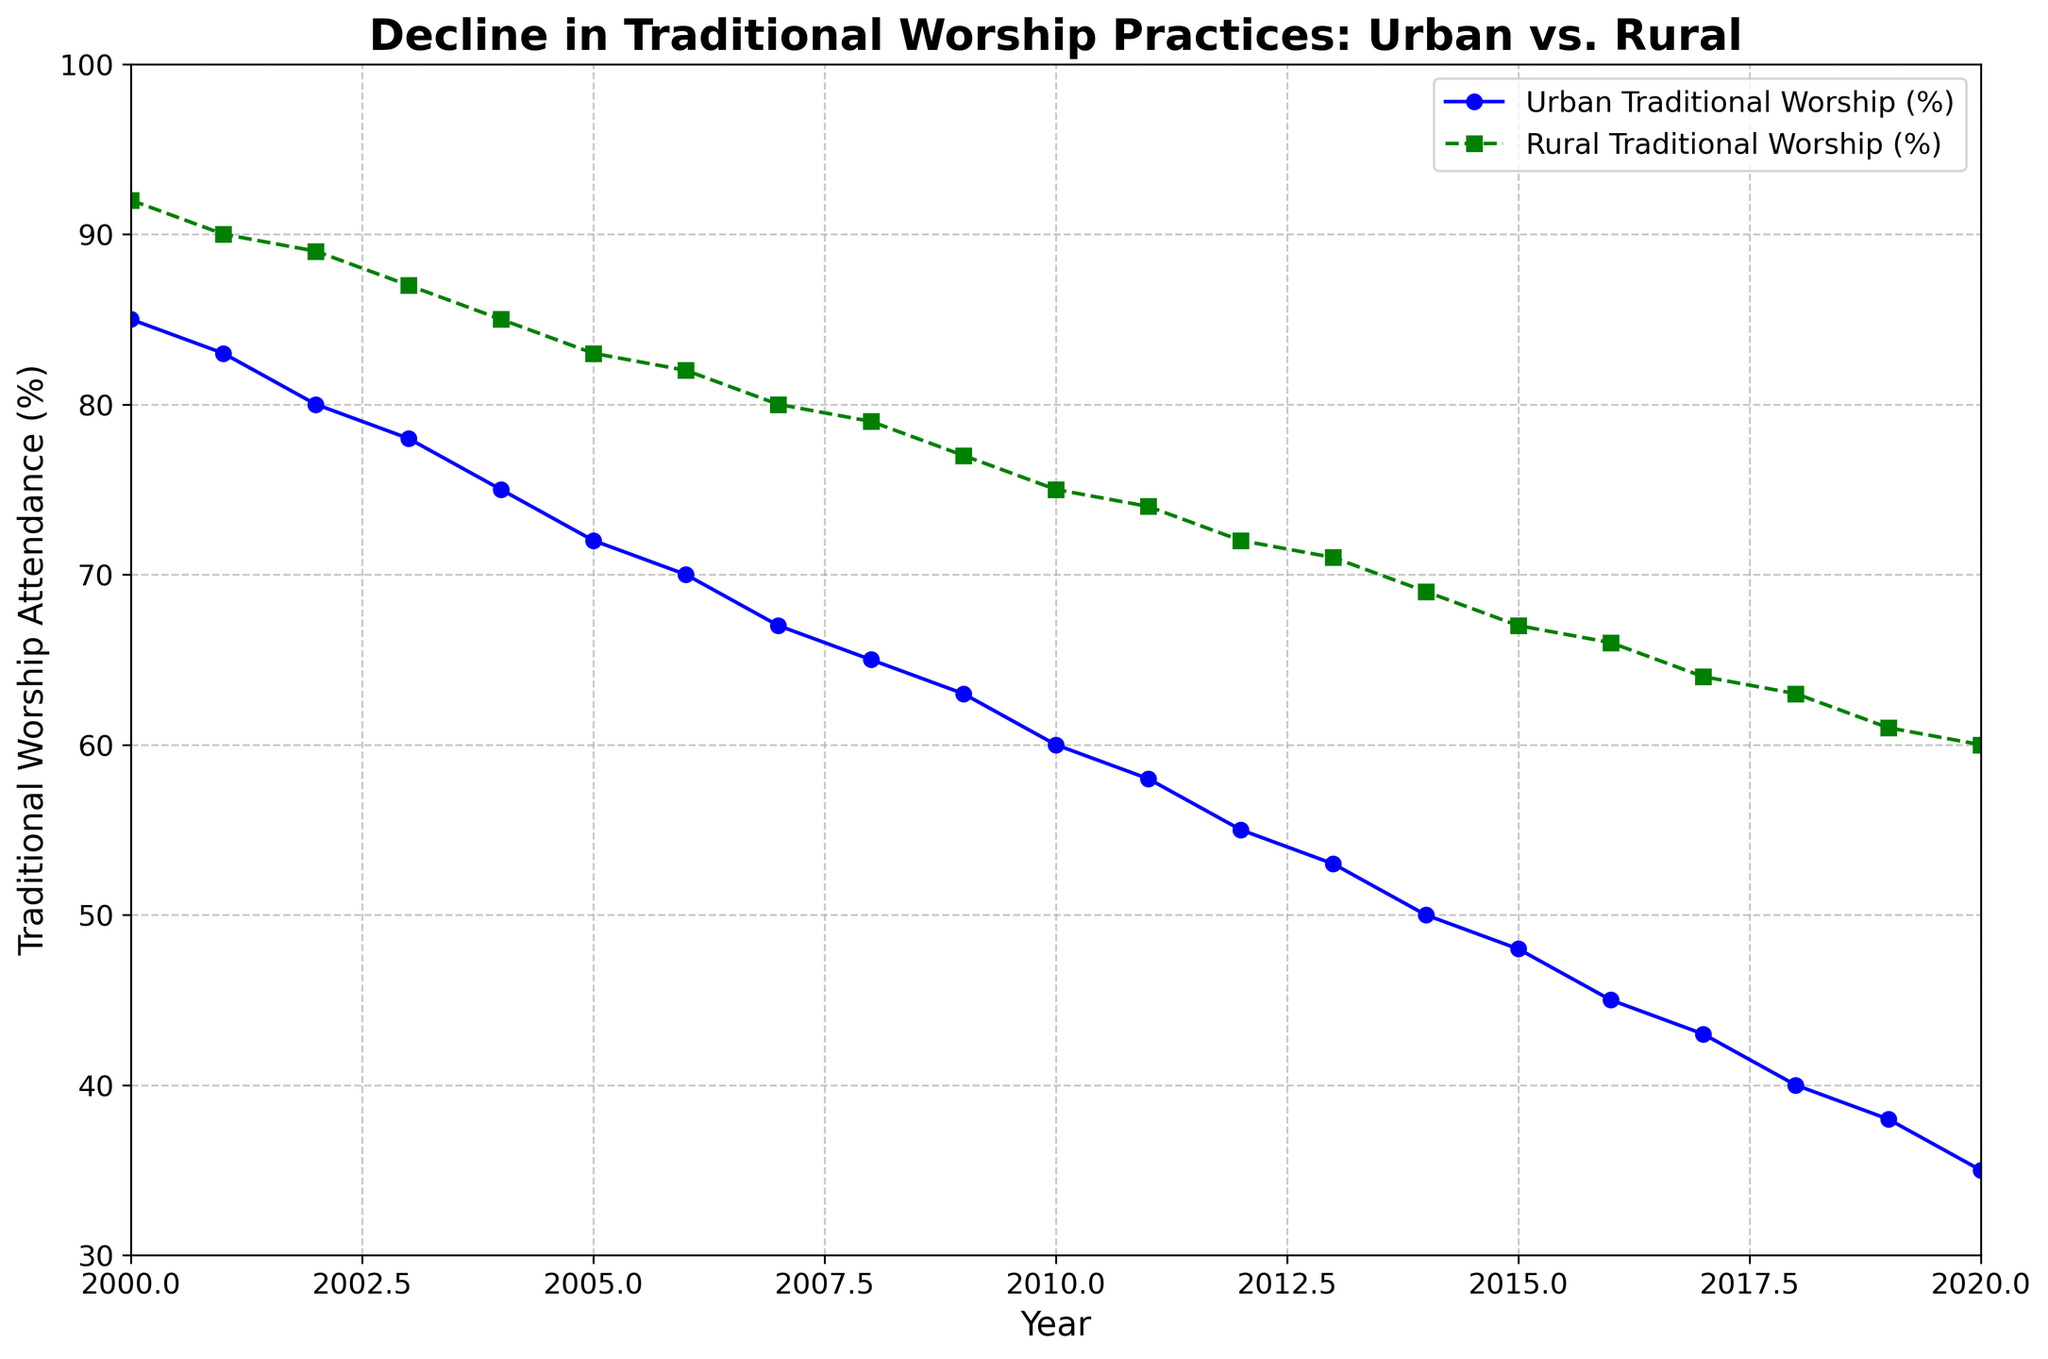What is the decline in the percentage of traditional worship practices in urban communities from 2000 to 2020? The percentage of traditional worship practices in urban communities was 85% in 2000 and declined to 35% in 2020. The decline can be calculated as 85% - 35% = 50%.
Answer: 50% In which year did rural traditional worship practices fall below 80%? By observing the green line for rural traditional worship practices, it is evident that in 2007 the percentage was 80, and in 2008 it fell to 79, indicating 2008 is the first year it fell below 80%.
Answer: 2008 How do the rates of decline in traditional worship attendance compare between urban and rural areas from 2000 to 2020? Urban traditional worship declined from 85% to 35%, a decrease of 50 percentage points over 20 years. Rural traditional worship declined from 92% to 60%, a decrease of 32 percentage points over the same period. The urban decline (50 points) is greater than the rural decline (32 points).
Answer: Urban decline is greater By what percentage did rural traditional worship practices decline from 2000 to 2010? In 2000, rural traditional worship was at 92%, and by 2010 it was at 75%. The percentage decline is calculated as ((92% - 75%) / 92%) * 100 = 18.48%.
Answer: 18.48% What is the difference in the percentage of traditional worship attendance between urban and rural areas in 2015? In 2015, urban traditional worship attendance was 48% and rural traditional worship attendance was 67%. The difference can be calculated as 67% - 48% = 19%.
Answer: 19% What year marks the sharpest one-year decline in urban traditional worship practices? By examining the blue line representing urban traditional worship practices, the sharpest decline appears between 2001 and 2002, with a drop from 83% to 80%, a 3% decrease.
Answer: 2002 Which community experienced a steeper decline in traditional worship attendance between 2008 and 2020? Urban traditional worship declined from 65% in 2008 to 35% in 2020, a decline of 30 percentage points. Rural traditional worship declined from 79% in 2008 to 60% in 2020, a decline of 19 percentage points. The urban community experienced a steeper decline.
Answer: Urban community Describe the trend in rural traditional worship attendance from 2000 to 2020 using the visual attributes of the figure. The green dashed line representing rural traditional worship attendance shows a consistent downward trend from 92% in 2000 to 60% in 2020. The rate of decline appears steady over the years.
Answer: Consistent downward trend What is the visual difference between how urban and rural traditional worship practices are represented in the figure? Urban traditional worship practices are shown by a solid blue line with circular markers, while rural traditional worship practices are represented by a dashed green line with square markers.
Answer: Solid blue line with circles and dashed green line with squares 